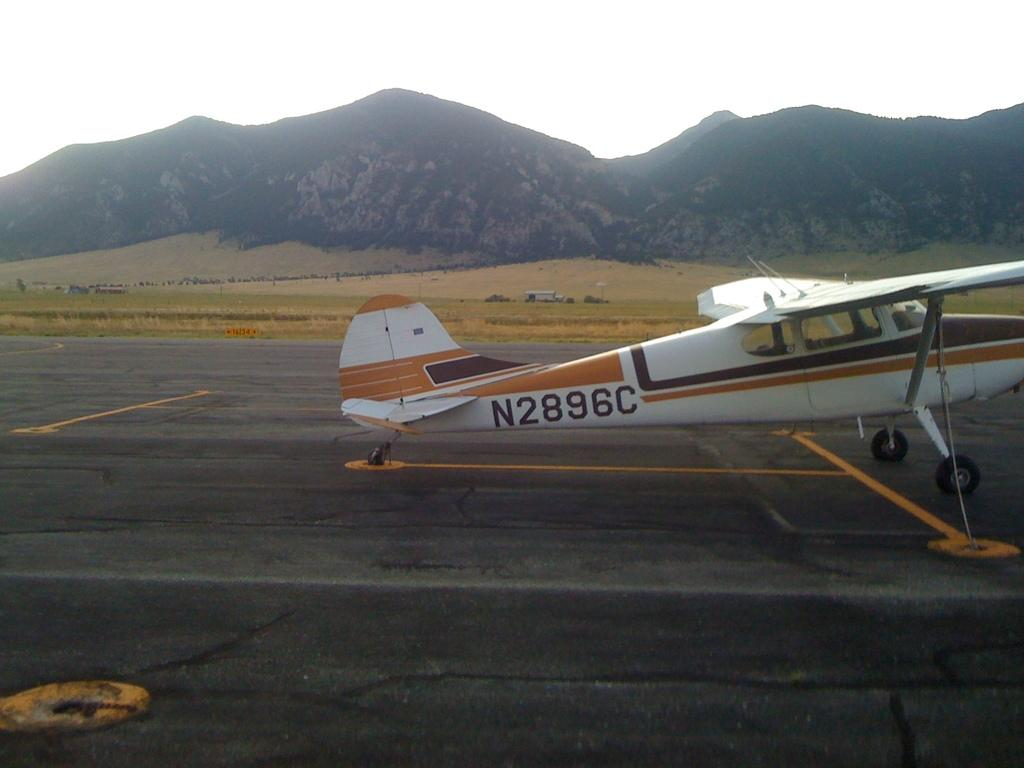What is the main subject of the image? The main subject of the image is an aircraft. What else can be seen in the image besides the aircraft? There is a road, grass, hills, and the sky visible in the image. Can you describe the landscape in the image? The landscape includes grass and hills. What is visible in the sky in the image? The sky is visible in the image. What type of friction can be observed between the aircraft and the road in the image? There is no friction between the aircraft and the road in the image, as they are separate elements in the landscape. What experience might the aircraft be having in the image? The image does not provide any information about the experience of the aircraft. --- 